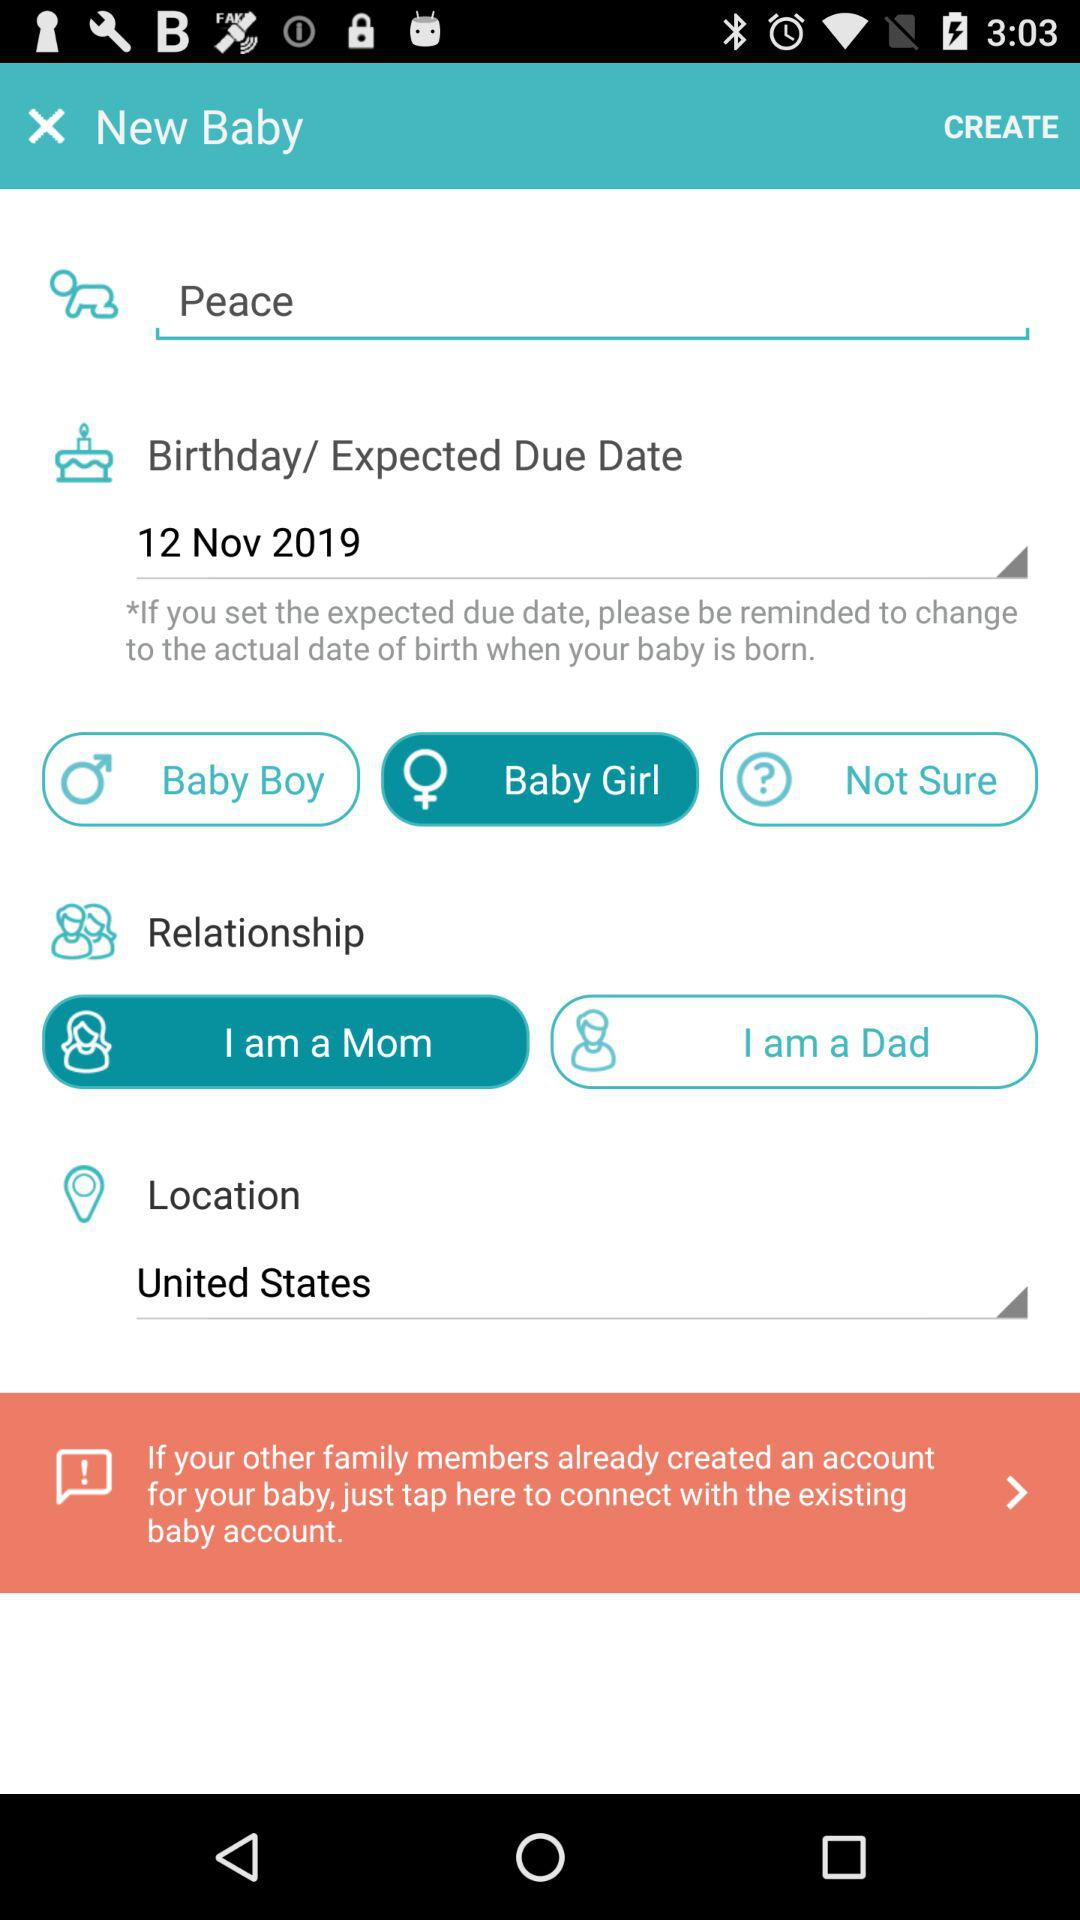When is the birthday? The birthday is on November 12, 2019. 